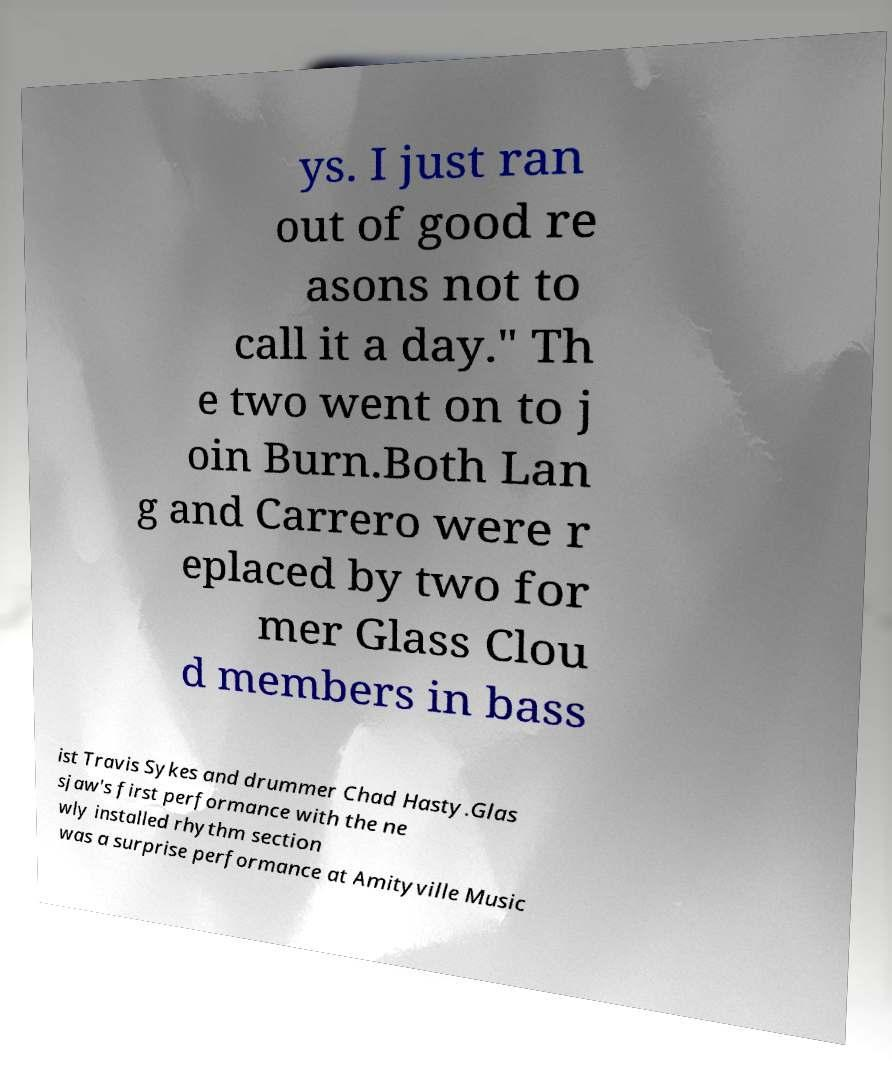Could you extract and type out the text from this image? ys. I just ran out of good re asons not to call it a day." Th e two went on to j oin Burn.Both Lan g and Carrero were r eplaced by two for mer Glass Clou d members in bass ist Travis Sykes and drummer Chad Hasty.Glas sjaw's first performance with the ne wly installed rhythm section was a surprise performance at Amityville Music 